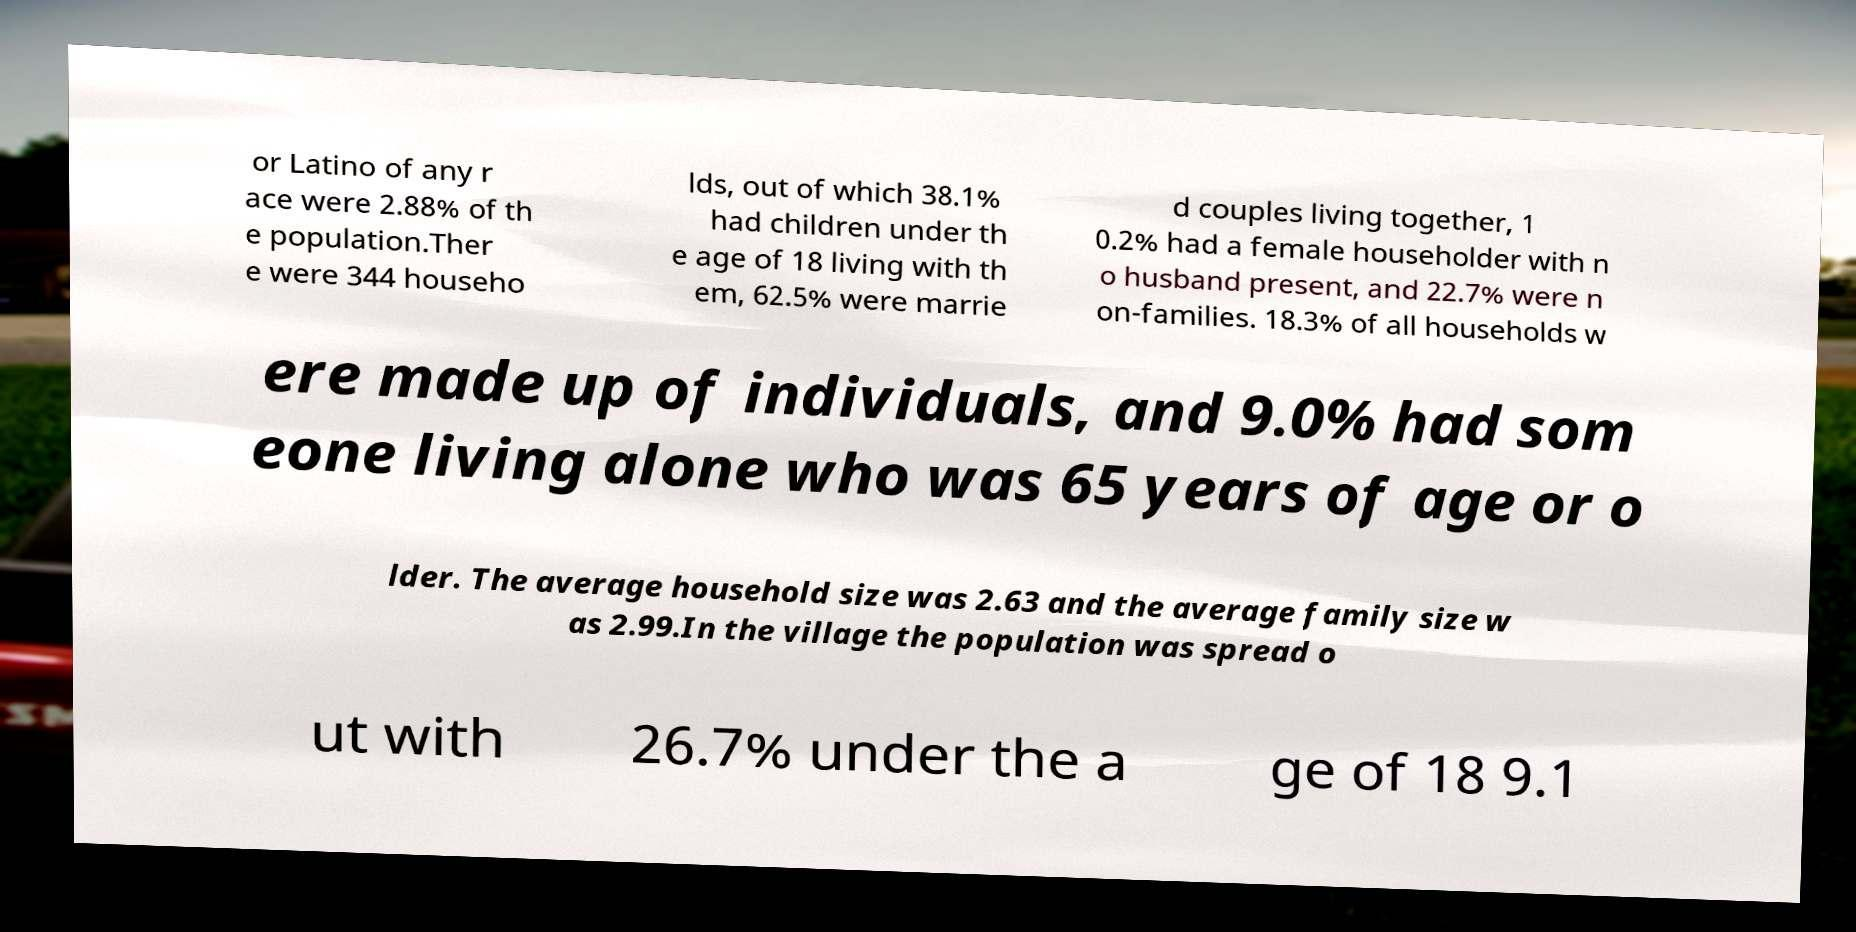For documentation purposes, I need the text within this image transcribed. Could you provide that? or Latino of any r ace were 2.88% of th e population.Ther e were 344 househo lds, out of which 38.1% had children under th e age of 18 living with th em, 62.5% were marrie d couples living together, 1 0.2% had a female householder with n o husband present, and 22.7% were n on-families. 18.3% of all households w ere made up of individuals, and 9.0% had som eone living alone who was 65 years of age or o lder. The average household size was 2.63 and the average family size w as 2.99.In the village the population was spread o ut with 26.7% under the a ge of 18 9.1 